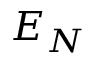Convert formula to latex. <formula><loc_0><loc_0><loc_500><loc_500>E _ { N }</formula> 